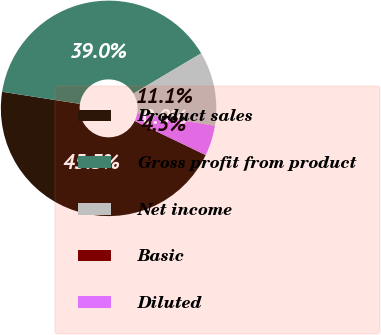Convert chart to OTSL. <chart><loc_0><loc_0><loc_500><loc_500><pie_chart><fcel>Product sales<fcel>Gross profit from product<fcel>Net income<fcel>Basic<fcel>Diluted<nl><fcel>45.32%<fcel>39.0%<fcel>11.12%<fcel>0.01%<fcel>4.54%<nl></chart> 